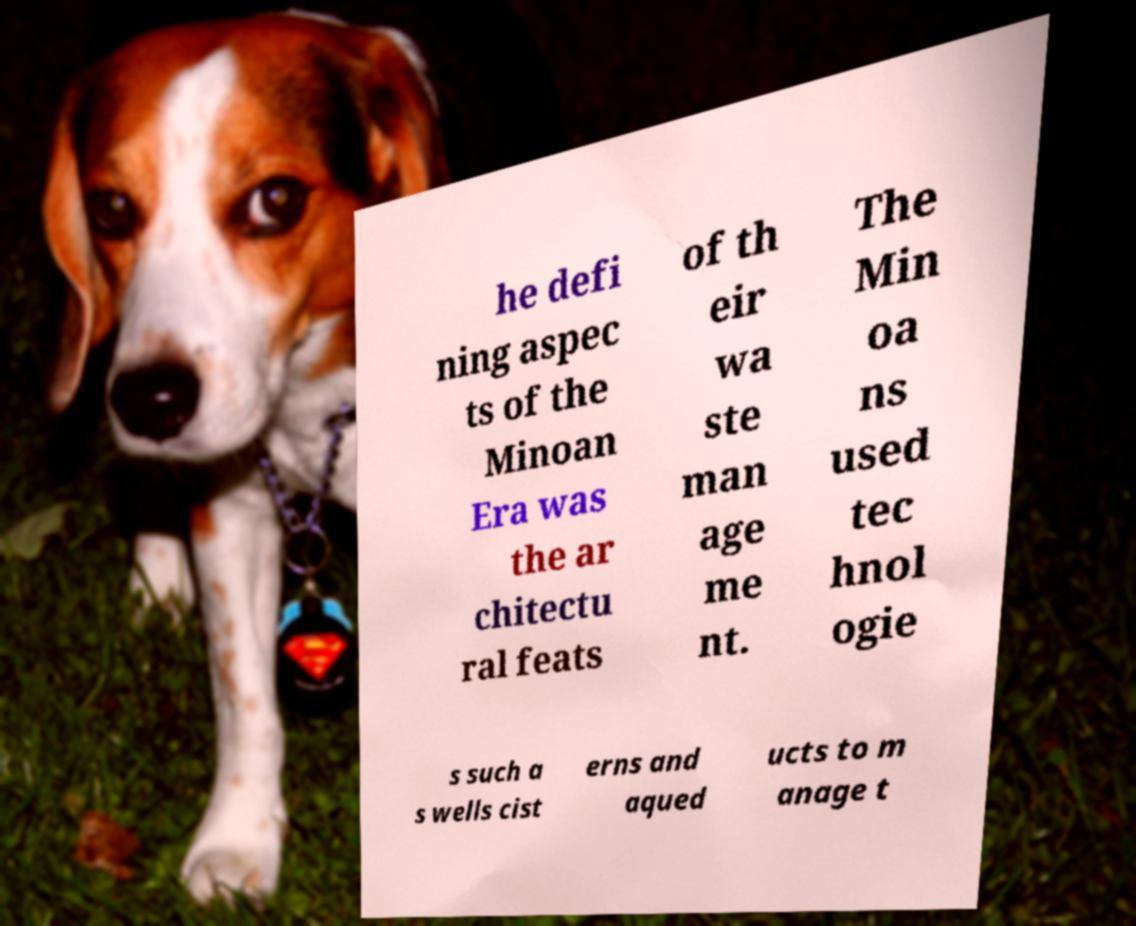Please read and relay the text visible in this image. What does it say? he defi ning aspec ts of the Minoan Era was the ar chitectu ral feats of th eir wa ste man age me nt. The Min oa ns used tec hnol ogie s such a s wells cist erns and aqued ucts to m anage t 